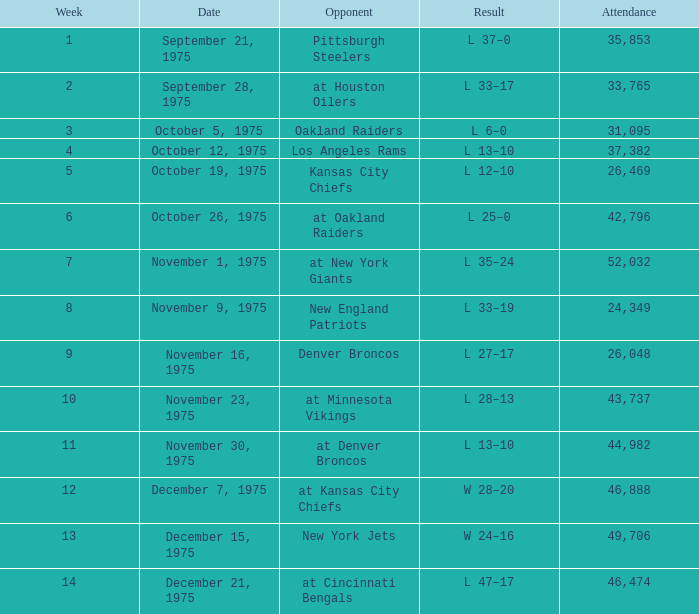What is the highest Week when the opponent was kansas city chiefs, with more than 26,469 in attendance? None. 